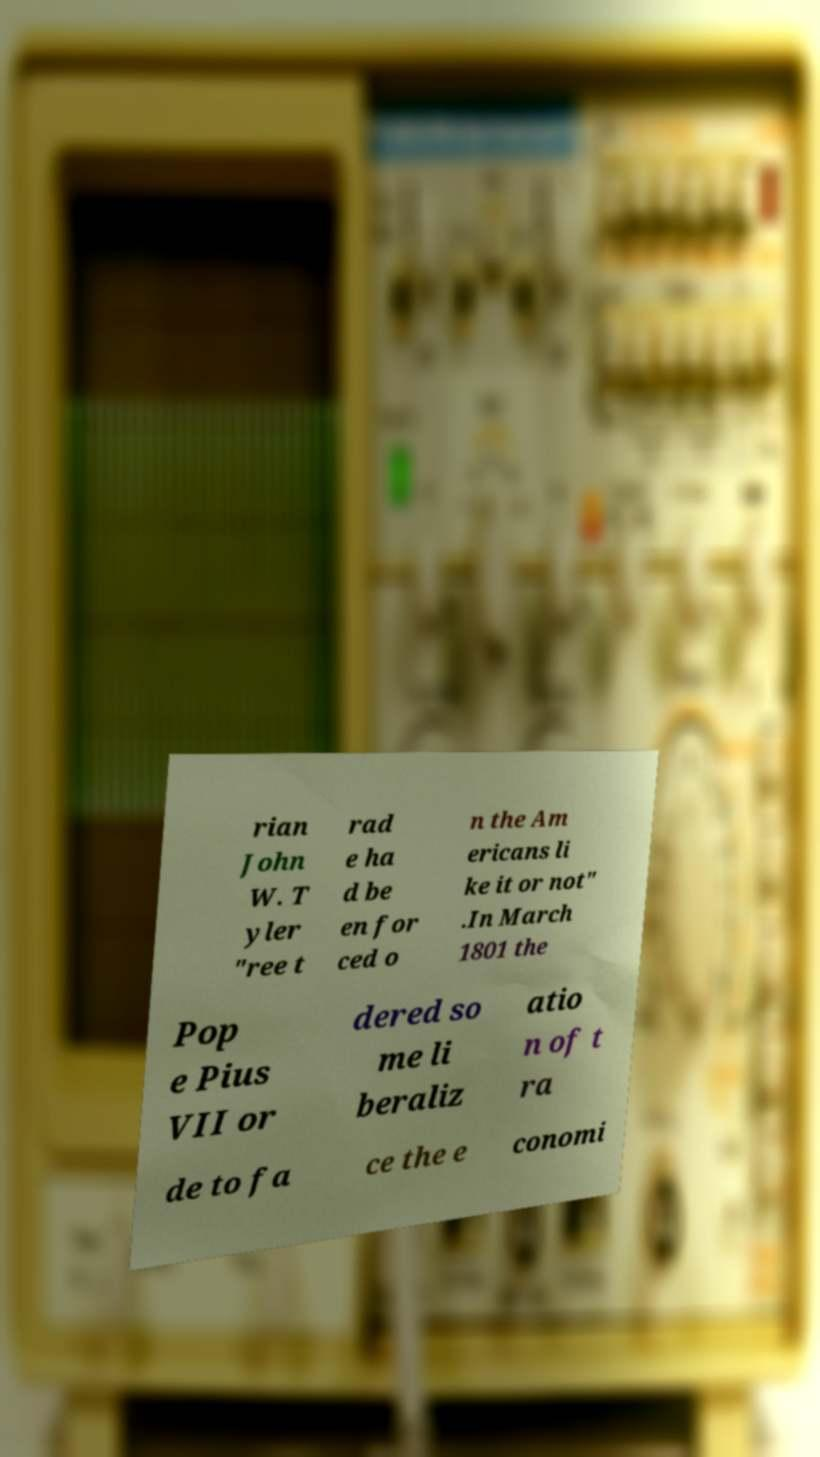Please identify and transcribe the text found in this image. rian John W. T yler "ree t rad e ha d be en for ced o n the Am ericans li ke it or not" .In March 1801 the Pop e Pius VII or dered so me li beraliz atio n of t ra de to fa ce the e conomi 